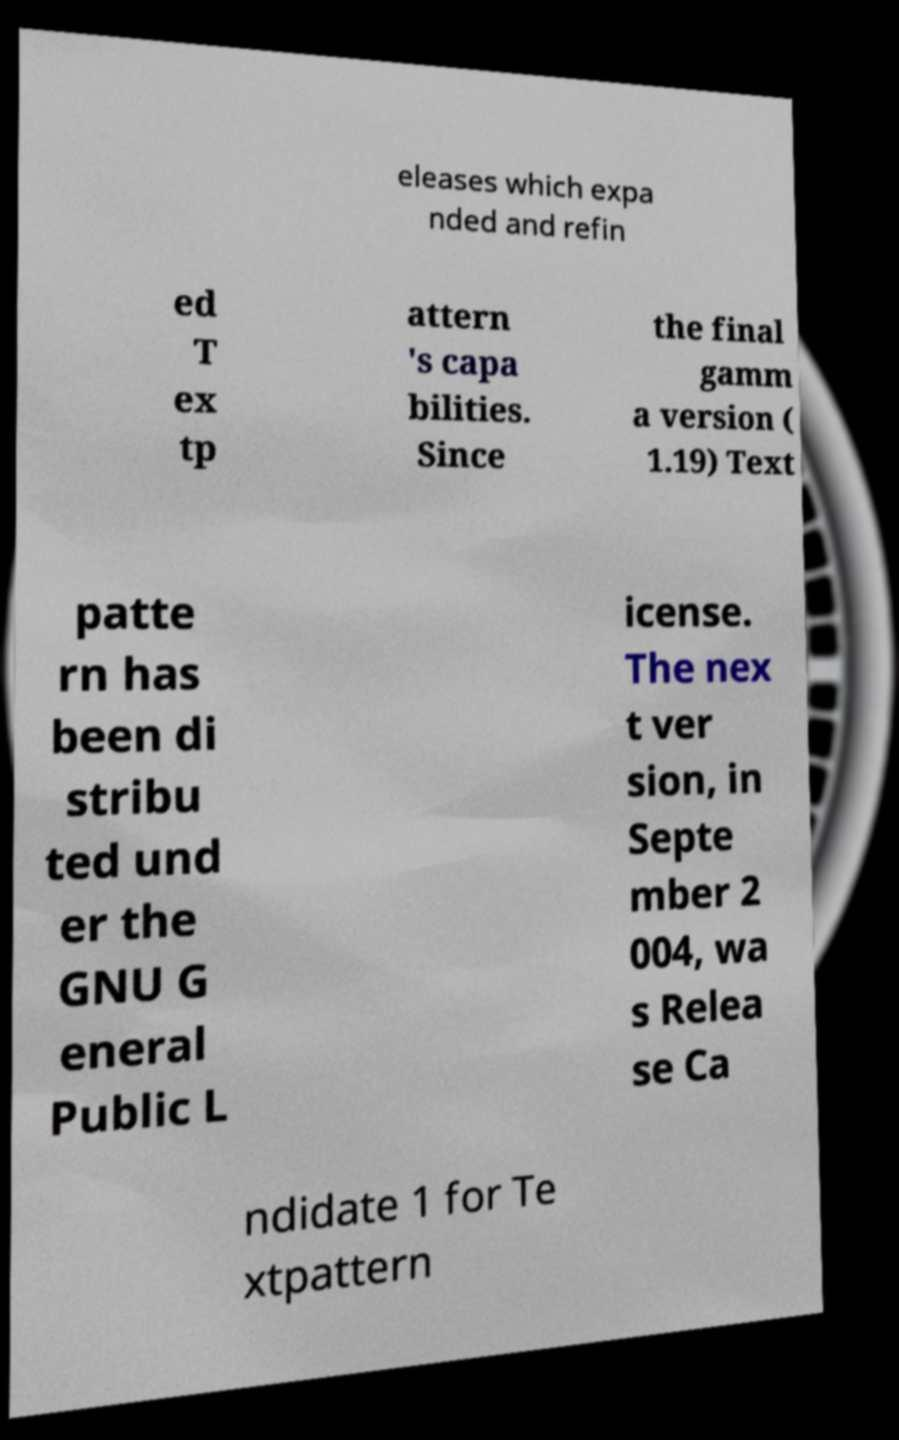What messages or text are displayed in this image? I need them in a readable, typed format. eleases which expa nded and refin ed T ex tp attern 's capa bilities. Since the final gamm a version ( 1.19) Text patte rn has been di stribu ted und er the GNU G eneral Public L icense. The nex t ver sion, in Septe mber 2 004, wa s Relea se Ca ndidate 1 for Te xtpattern 